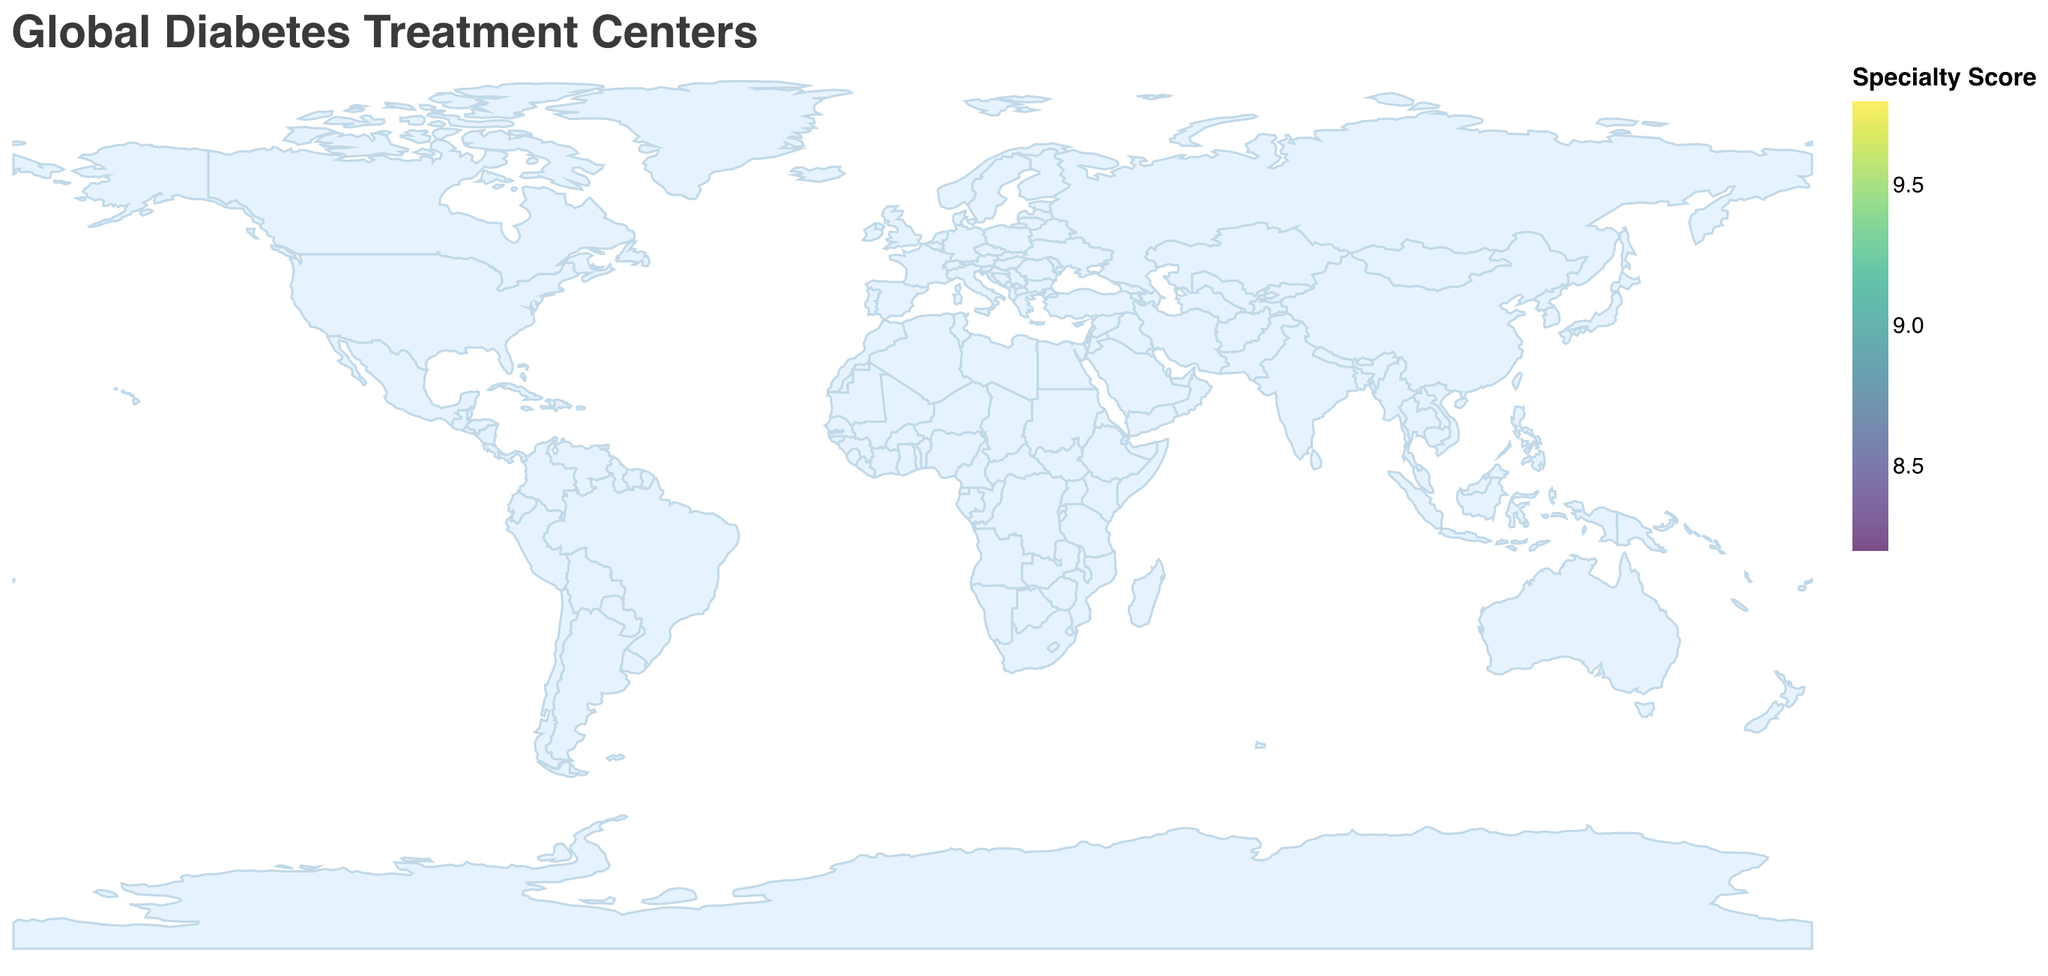What's the title of the plot? The title of the plot is displayed at the top, which is "Global Diabetes Treatment Centers."
Answer: Global Diabetes Treatment Centers How many facilities are shown in the plot? The plot displays circles on the map and each circle represents a healthcare facility. By counting these circles, we can see that there are 12 facilities shown in the plot.
Answer: 12 Which country has the facility with the highest specialty score? By examining the coloring and size of the circles and checking the tooltip information by hovering over each one, we see that the facility with the highest specialty score, 9.8, is located in the USA in Boston.
Answer: USA What is the average specialty score of the facilities in the plot? Sum the specialty scores of all facilities (9.8 + 9.5 + 9.3 + 9.0 + 8.7 + 8.5 + 8.9 + 8.2 + 9.6 + 8.8 + 9.1 + 8.4) = 107.8, then divide by the number of facilities (12): 107.8 / 12 = 8.98.
Answer: 8.98 Which facility is located at the highest latitude? By looking at the latitude coordinates for all the facilities, the highest latitude is 55.7309 which corresponds to the Steno Diabetes Center in Copenhagen, Denmark.
Answer: Steno Diabetes Center What is the difference in specialty score between the facility in Boston and the one in São Paulo? The specialty score for the facility in Boston is 9.8, and for the facility in São Paulo, it is 8.2. The difference is 9.8 - 8.2 = 1.6.
Answer: 1.6 Which continent has the most represented facilities on the map? By identifying the continents for each facility, we notice that multiple facilities are from different continents. Europe is represented by facilities in the UK, Germany, Denmark, and France, totaling 4 facilities, which is the most.
Answer: Europe Are there more facilities in the northern or southern hemisphere? By examining the latitudes, we see which facilities are in the northern hemisphere (positive latitude values) and which are in the southern hemisphere (negative latitude values). There are 10 facilities in the northern hemisphere and 2 in the southern hemisphere.
Answer: Northern hemisphere What is the specialty score of the facility located in Paris? Hovering over or checking the tooltip for the circle located in Paris reveals that the specialty score of Hôpital Pitié-Salpêtrière Diabetes Department is 9.1.
Answer: 9.1 Which facility is closest to the Equator? By comparing the absolute value of latitudes (since the Equator is latitude 0), the facility in Singapore (latitude 1.2789) is closest to the Equator.
Answer: Singapore General Hospital Diabetes Centre 